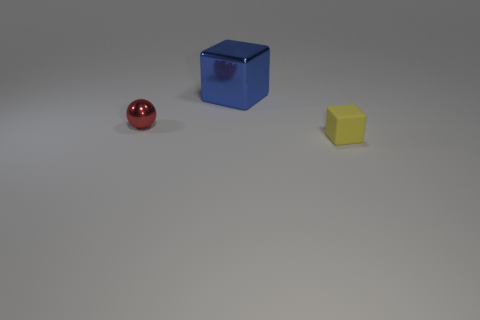Do the small object that is to the left of the yellow matte block and the small yellow thing have the same material?
Give a very brief answer. No. There is a thing behind the tiny metallic thing that is in front of the large blue metal object; what color is it?
Make the answer very short. Blue. What is the shape of the yellow rubber object that is the same size as the red metallic sphere?
Keep it short and to the point. Cube. Is the number of shiny things in front of the tiny ball the same as the number of large yellow shiny blocks?
Your answer should be very brief. Yes. There is a block in front of the metallic thing right of the small object that is on the left side of the tiny yellow matte object; what is its material?
Offer a terse response. Rubber. What is the shape of the small red object that is the same material as the blue thing?
Give a very brief answer. Sphere. What number of big cubes are in front of the tiny object that is left of the tiny block that is right of the red shiny ball?
Make the answer very short. 0. What number of blue things are tiny cubes or large metallic cubes?
Your response must be concise. 1. Does the rubber thing have the same size as the shiny thing that is behind the tiny sphere?
Provide a short and direct response. No. What is the material of the other thing that is the same shape as the matte object?
Give a very brief answer. Metal. 